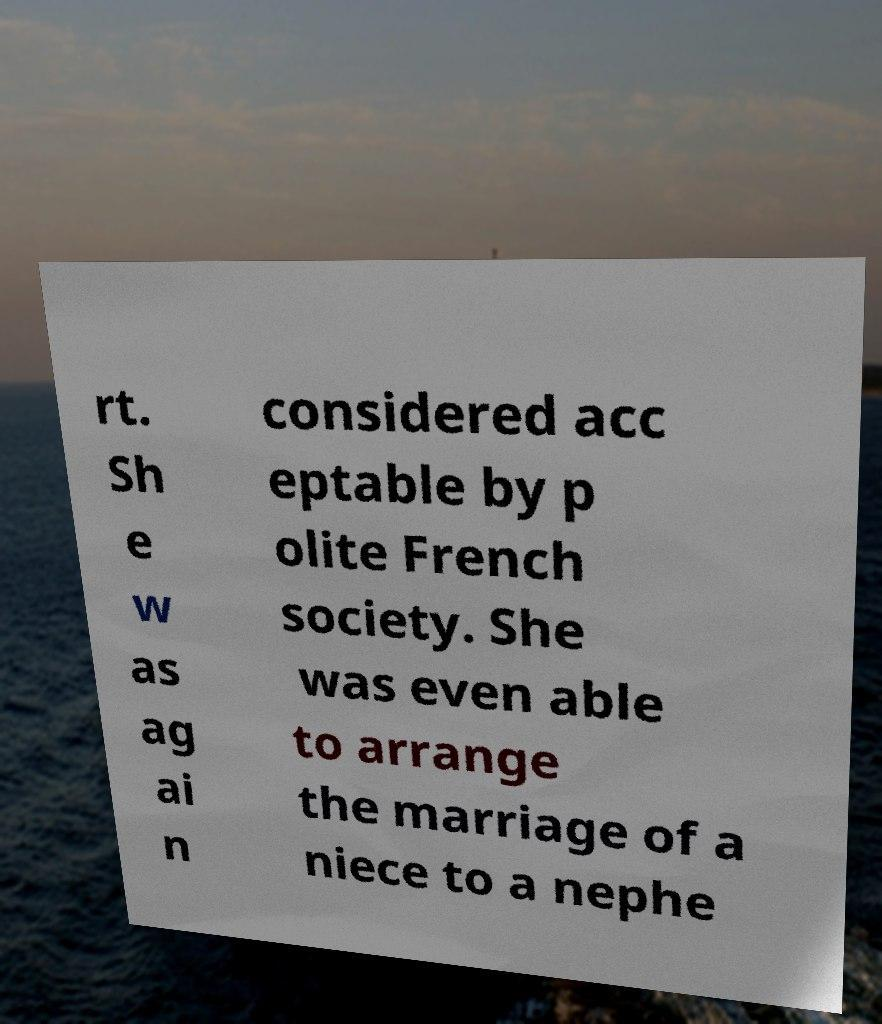For documentation purposes, I need the text within this image transcribed. Could you provide that? rt. Sh e w as ag ai n considered acc eptable by p olite French society. She was even able to arrange the marriage of a niece to a nephe 